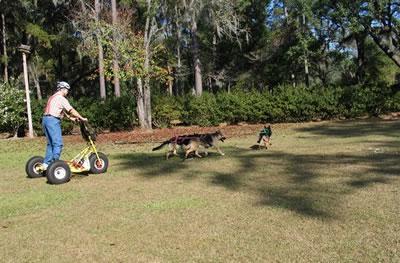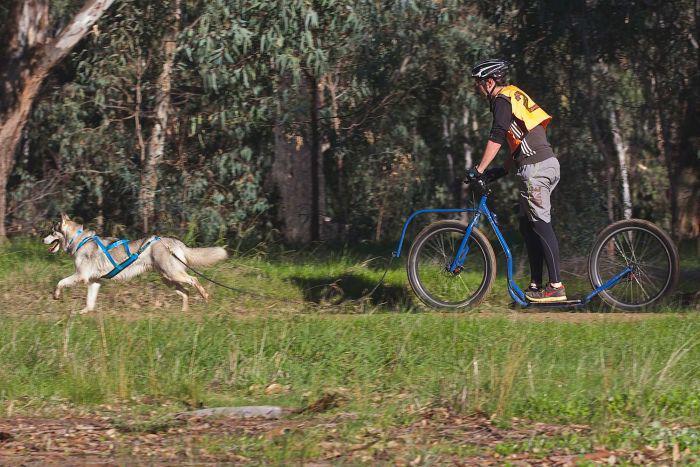The first image is the image on the left, the second image is the image on the right. Examine the images to the left and right. Is the description "There are two dogs." accurate? Answer yes or no. No. The first image is the image on the left, the second image is the image on the right. Evaluate the accuracy of this statement regarding the images: "An image shows a person in a helmet riding a four-wheeled cart pulled by one dog diagonally to the right.". Is it true? Answer yes or no. No. 